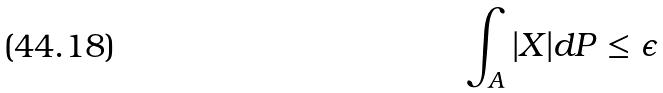<formula> <loc_0><loc_0><loc_500><loc_500>\int _ { A } | X | d P \leq \epsilon</formula> 